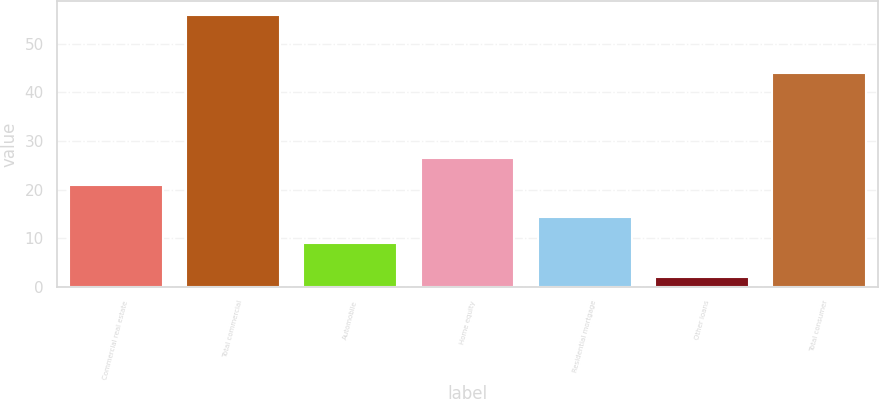Convert chart to OTSL. <chart><loc_0><loc_0><loc_500><loc_500><bar_chart><fcel>Commercial real estate<fcel>Total commercial<fcel>Automobile<fcel>Home equity<fcel>Residential mortgage<fcel>Other loans<fcel>Total consumer<nl><fcel>21<fcel>56<fcel>9<fcel>26.4<fcel>14.4<fcel>2<fcel>44<nl></chart> 